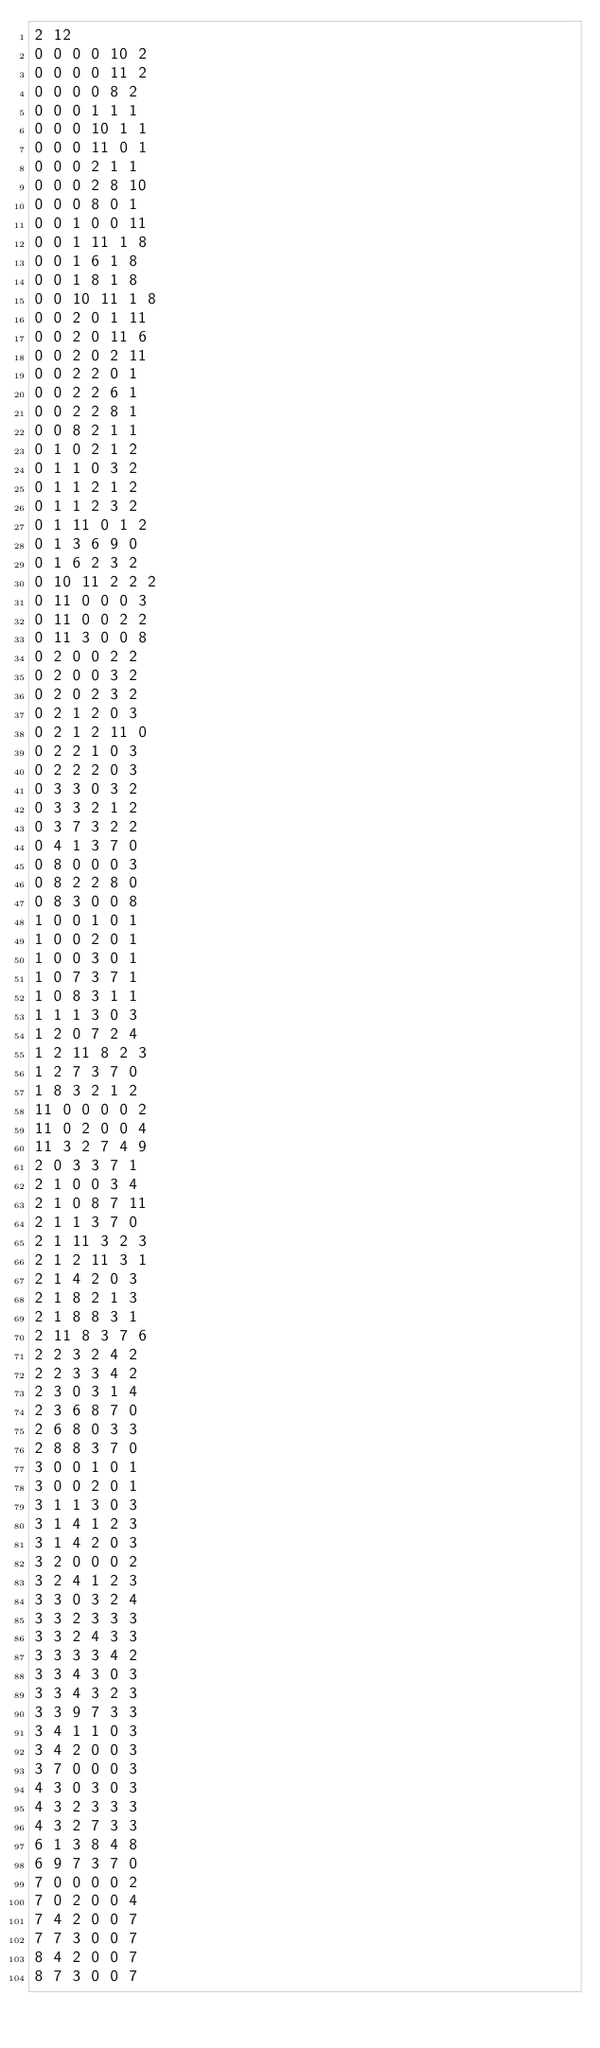Convert code to text. <code><loc_0><loc_0><loc_500><loc_500><_SQL_>2 12
0 0 0 0 10 2
0 0 0 0 11 2
0 0 0 0 8 2
0 0 0 1 1 1
0 0 0 10 1 1
0 0 0 11 0 1
0 0 0 2 1 1
0 0 0 2 8 10
0 0 0 8 0 1
0 0 1 0 0 11
0 0 1 11 1 8
0 0 1 6 1 8
0 0 1 8 1 8
0 0 10 11 1 8
0 0 2 0 1 11
0 0 2 0 11 6
0 0 2 0 2 11
0 0 2 2 0 1
0 0 2 2 6 1
0 0 2 2 8 1
0 0 8 2 1 1
0 1 0 2 1 2
0 1 1 0 3 2
0 1 1 2 1 2
0 1 1 2 3 2
0 1 11 0 1 2
0 1 3 6 9 0
0 1 6 2 3 2
0 10 11 2 2 2
0 11 0 0 0 3
0 11 0 0 2 2
0 11 3 0 0 8
0 2 0 0 2 2
0 2 0 0 3 2
0 2 0 2 3 2
0 2 1 2 0 3
0 2 1 2 11 0
0 2 2 1 0 3
0 2 2 2 0 3
0 3 3 0 3 2
0 3 3 2 1 2
0 3 7 3 2 2
0 4 1 3 7 0
0 8 0 0 0 3
0 8 2 2 8 0
0 8 3 0 0 8
1 0 0 1 0 1
1 0 0 2 0 1
1 0 0 3 0 1
1 0 7 3 7 1
1 0 8 3 1 1
1 1 1 3 0 3
1 2 0 7 2 4
1 2 11 8 2 3
1 2 7 3 7 0
1 8 3 2 1 2
11 0 0 0 0 2
11 0 2 0 0 4
11 3 2 7 4 9
2 0 3 3 7 1
2 1 0 0 3 4
2 1 0 8 7 11
2 1 1 3 7 0
2 1 11 3 2 3
2 1 2 11 3 1
2 1 4 2 0 3
2 1 8 2 1 3
2 1 8 8 3 1
2 11 8 3 7 6
2 2 3 2 4 2
2 2 3 3 4 2
2 3 0 3 1 4
2 3 6 8 7 0
2 6 8 0 3 3
2 8 8 3 7 0
3 0 0 1 0 1
3 0 0 2 0 1
3 1 1 3 0 3
3 1 4 1 2 3
3 1 4 2 0 3
3 2 0 0 0 2
3 2 4 1 2 3
3 3 0 3 2 4
3 3 2 3 3 3
3 3 2 4 3 3
3 3 3 3 4 2
3 3 4 3 0 3
3 3 4 3 2 3
3 3 9 7 3 3
3 4 1 1 0 3
3 4 2 0 0 3
3 7 0 0 0 3
4 3 0 3 0 3
4 3 2 3 3 3
4 3 2 7 3 3
6 1 3 8 4 8
6 9 7 3 7 0
7 0 0 0 0 2
7 0 2 0 0 4
7 4 2 0 0 7
7 7 3 0 0 7
8 4 2 0 0 7
8 7 3 0 0 7
</code> 